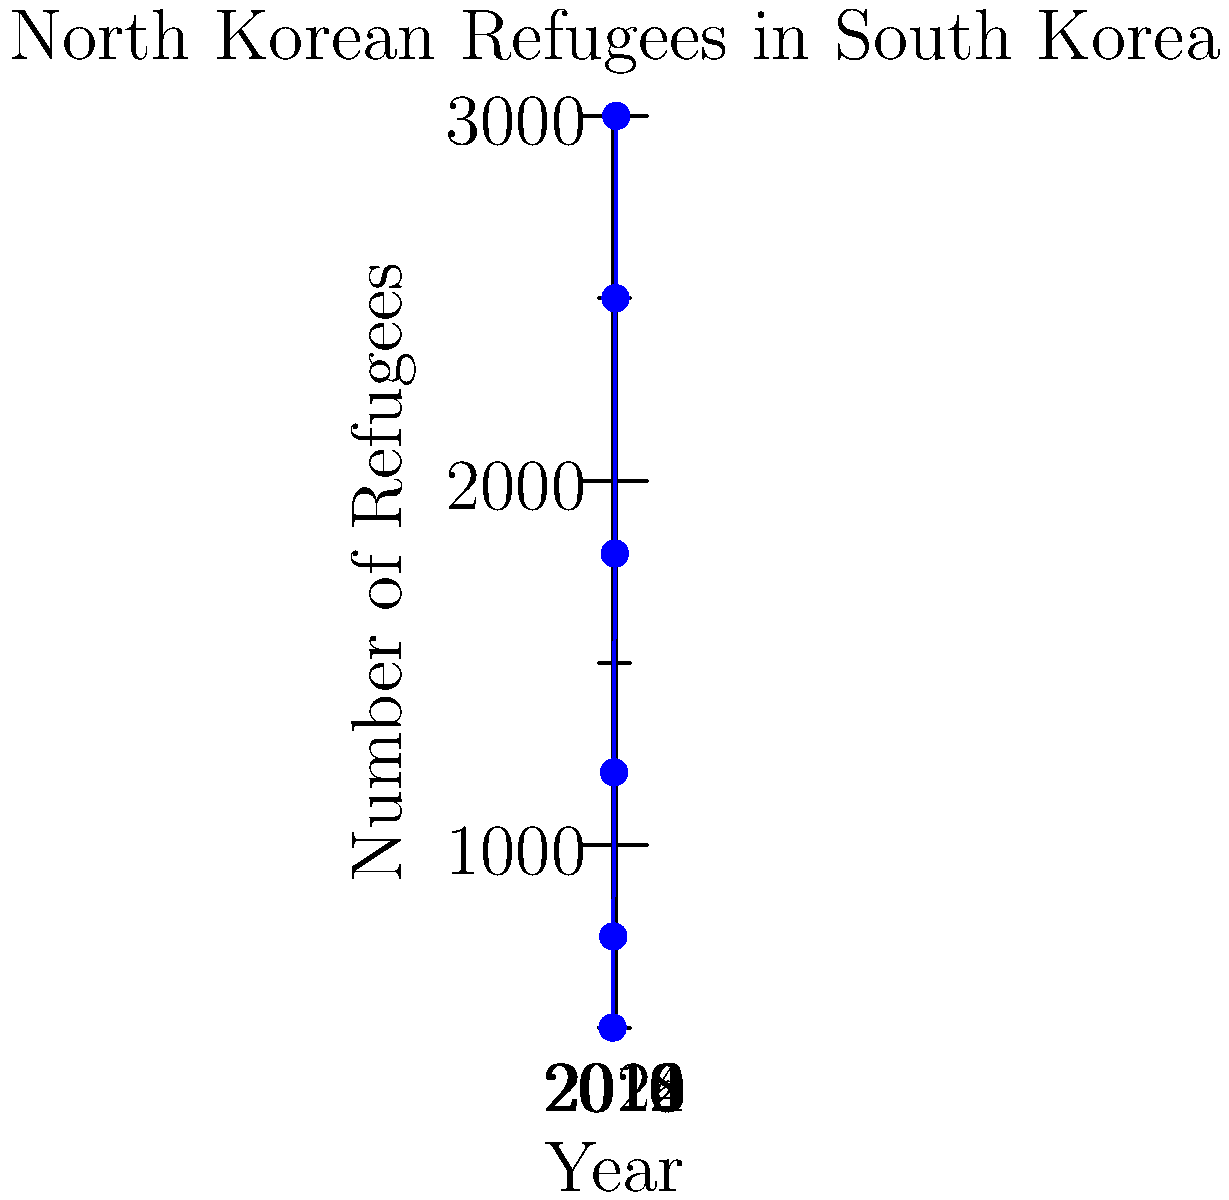The graph shows the number of North Korean refugees in South Korea from 2010 to 2020. What was the average annual increase in the number of refugees during this period? To find the average annual increase in the number of refugees:

1. Calculate total increase:
   Final value (2020) - Initial value (2010) = 3000 - 500 = 2500

2. Determine the number of years:
   2020 - 2010 = 10 years

3. Calculate average annual increase:
   Total increase ÷ Number of years
   $\frac{2500}{10} = 250$

Therefore, the average annual increase in the number of refugees was 250 per year.

This analysis is particularly relevant for a restaurant owner serving traditional Korean cuisine and fostering a community for fellow defectors, as it provides insight into the growing potential customer base and community members.
Answer: 250 refugees per year 